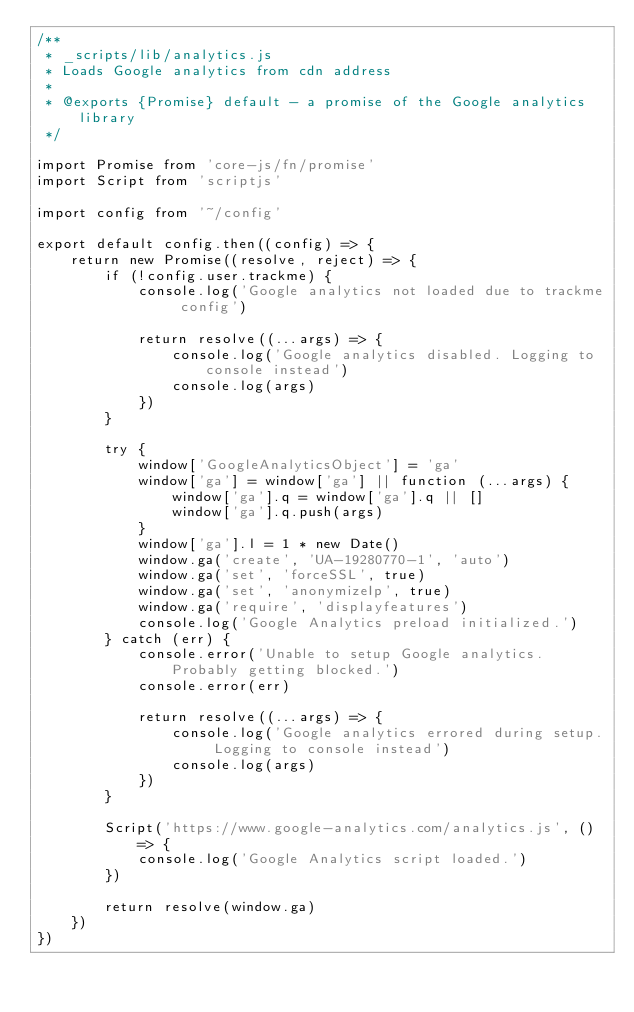<code> <loc_0><loc_0><loc_500><loc_500><_JavaScript_>/**
 * _scripts/lib/analytics.js
 * Loads Google analytics from cdn address
 *
 * @exports {Promise} default - a promise of the Google analytics library
 */

import Promise from 'core-js/fn/promise'
import Script from 'scriptjs'

import config from '~/config'

export default config.then((config) => {
    return new Promise((resolve, reject) => {
        if (!config.user.trackme) {
            console.log('Google analytics not loaded due to trackme config')

            return resolve((...args) => {
                console.log('Google analytics disabled. Logging to console instead')
                console.log(args)
            })
        }

        try {
            window['GoogleAnalyticsObject'] = 'ga'
            window['ga'] = window['ga'] || function (...args) {
                window['ga'].q = window['ga'].q || []
                window['ga'].q.push(args)
            }
            window['ga'].l = 1 * new Date()
            window.ga('create', 'UA-19280770-1', 'auto')
            window.ga('set', 'forceSSL', true)
            window.ga('set', 'anonymizeIp', true)
            window.ga('require', 'displayfeatures')
            console.log('Google Analytics preload initialized.')
        } catch (err) {
            console.error('Unable to setup Google analytics. Probably getting blocked.')
            console.error(err)

            return resolve((...args) => {
                console.log('Google analytics errored during setup. Logging to console instead')
                console.log(args)
            })
        }

        Script('https://www.google-analytics.com/analytics.js', () => {
            console.log('Google Analytics script loaded.')
        })

        return resolve(window.ga)
    })
})
</code> 